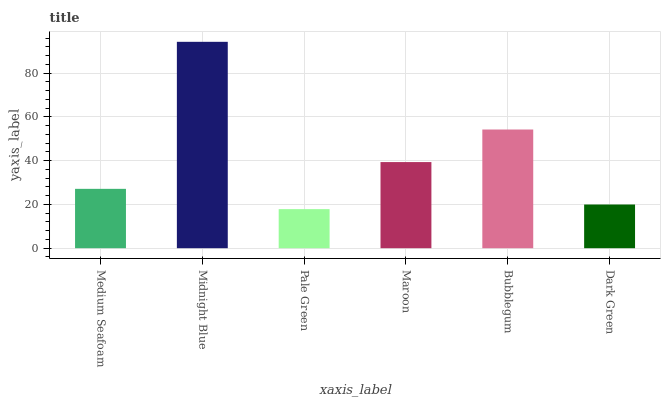Is Pale Green the minimum?
Answer yes or no. Yes. Is Midnight Blue the maximum?
Answer yes or no. Yes. Is Midnight Blue the minimum?
Answer yes or no. No. Is Pale Green the maximum?
Answer yes or no. No. Is Midnight Blue greater than Pale Green?
Answer yes or no. Yes. Is Pale Green less than Midnight Blue?
Answer yes or no. Yes. Is Pale Green greater than Midnight Blue?
Answer yes or no. No. Is Midnight Blue less than Pale Green?
Answer yes or no. No. Is Maroon the high median?
Answer yes or no. Yes. Is Medium Seafoam the low median?
Answer yes or no. Yes. Is Dark Green the high median?
Answer yes or no. No. Is Dark Green the low median?
Answer yes or no. No. 